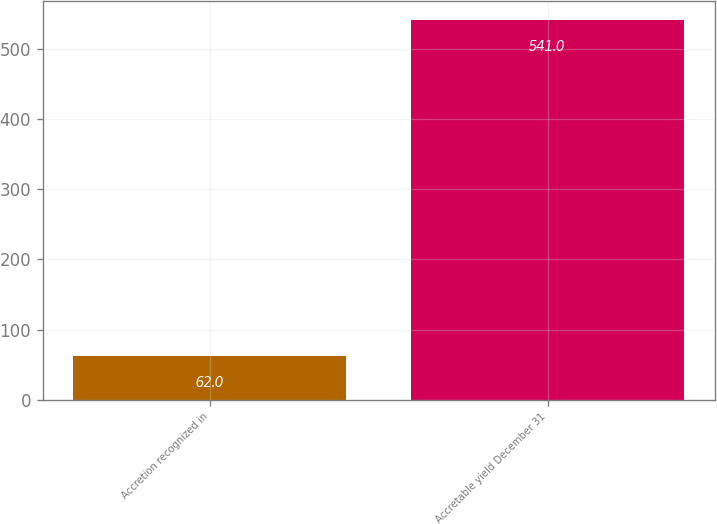Convert chart. <chart><loc_0><loc_0><loc_500><loc_500><bar_chart><fcel>Accretion recognized in<fcel>Accretable yield December 31<nl><fcel>62<fcel>541<nl></chart> 